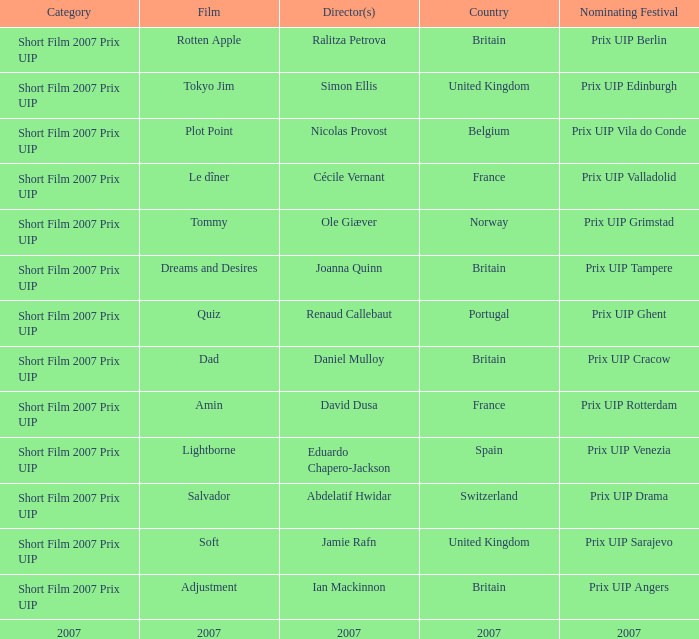What film did ian mackinnon direct that was in the short film 2007 prix uip category? Adjustment. 